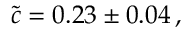<formula> <loc_0><loc_0><loc_500><loc_500>\tilde { c } = 0 . 2 3 \pm 0 . 0 4 \, ,</formula> 